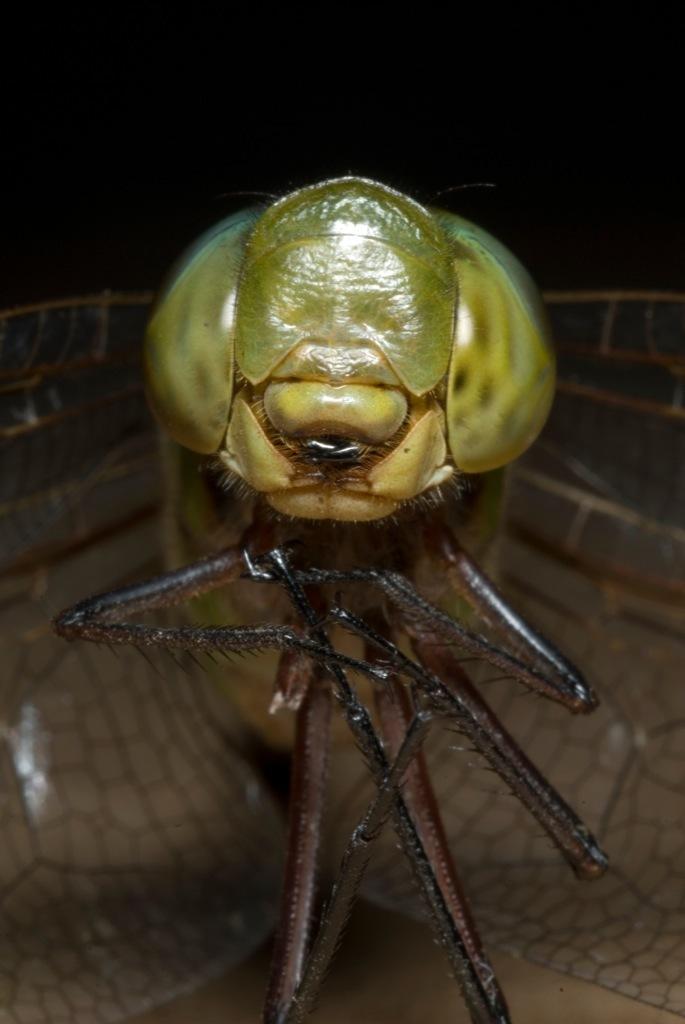How would you summarize this image in a sentence or two? In the picture we can see some fly. 